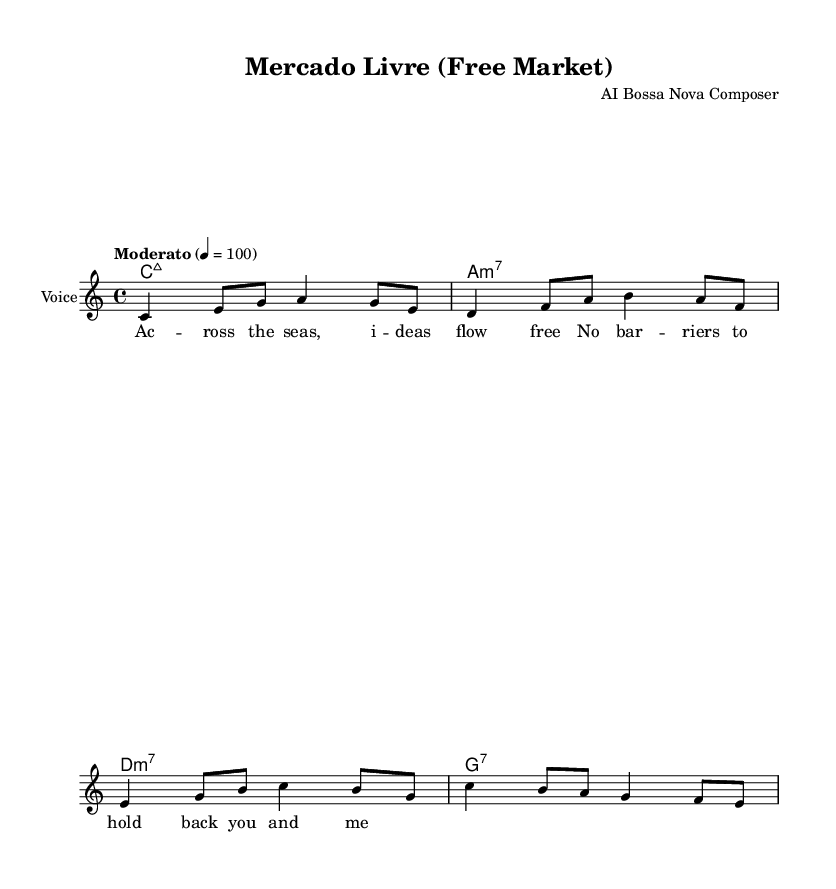What is the key signature of this music? The key signature is indicated at the beginning of the sheet music. It shows that there are no sharps or flats, which corresponds to C major.
Answer: C major What is the time signature of this music? The time signature is found after the clef sign at the beginning of the staff. It indicates that there are four beats per measure, represented by the '4/4' notation.
Answer: 4/4 What is the tempo marking for this piece? The tempo marking is located above the staff and states "Moderato" with a metronome marking of 100 beats per minute, indicating a moderate pace.
Answer: Moderato How many measures are in the melody? The melody section has four measures, which can be counted based on the grouping of notes and corresponding bar lines in the music.
Answer: Four What type of chord progression is used in this piece? The chord progression is deduced from the ChordNames section where it shows a sequence of four chords: C major 7, A minor 7, D minor 7, and G7, following a common jazz sequence.
Answer: Jazz sequence What is the main theme of the lyrics? The lyrics express the idea of free trade and the absence of barriers that facilitate the flow of ideas across borders, as evident in the text provided.
Answer: Free trade Which genre does this piece belong to? The genre is indicated by the title "Mercado Livre (Free Market)" and the style is characterized as Bossa Nova, a Brazilian music style that blends samba and jazz influences.
Answer: Bossa Nova 